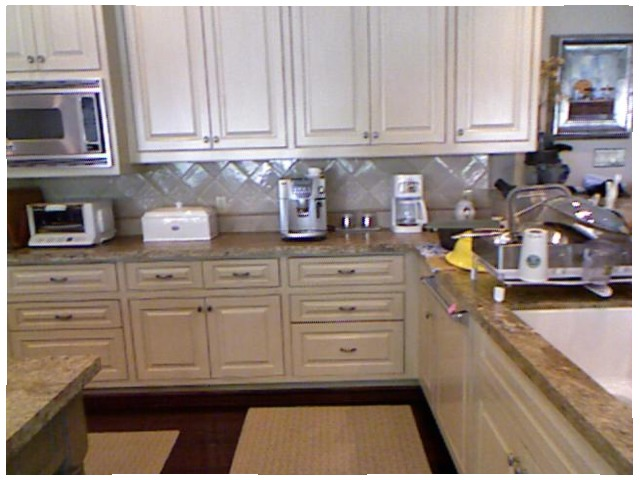<image>
Can you confirm if the coffee maker is on the counter? Yes. Looking at the image, I can see the coffee maker is positioned on top of the counter, with the counter providing support. Where is the cupboard in relation to the wall? Is it behind the wall? No. The cupboard is not behind the wall. From this viewpoint, the cupboard appears to be positioned elsewhere in the scene. Is there a glass behind the cup? No. The glass is not behind the cup. From this viewpoint, the glass appears to be positioned elsewhere in the scene. Is the microwave above the toaster? Yes. The microwave is positioned above the toaster in the vertical space, higher up in the scene. Is there a coffee machine to the right of the counter top? No. The coffee machine is not to the right of the counter top. The horizontal positioning shows a different relationship. Where is the kitchen gadget in relation to the sink? Is it to the left of the sink? Yes. From this viewpoint, the kitchen gadget is positioned to the left side relative to the sink. 